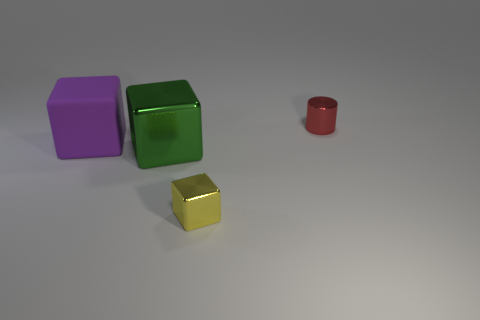What material is the tiny thing to the left of the tiny thing behind the tiny metallic object to the left of the small cylinder made of?
Give a very brief answer. Metal. What shape is the object that is right of the yellow shiny object?
Provide a succinct answer. Cylinder. What is the size of the yellow thing that is the same material as the tiny red thing?
Provide a short and direct response. Small. What number of big green things are the same shape as the large purple matte object?
Give a very brief answer. 1. How many tiny cylinders are behind the large purple cube that is behind the metal cube left of the small yellow block?
Give a very brief answer. 1. What number of things are behind the large shiny object and left of the small block?
Your answer should be very brief. 1. Is there any other thing that is the same material as the red cylinder?
Give a very brief answer. Yes. Is the material of the red object the same as the purple cube?
Make the answer very short. No. What is the shape of the object that is right of the tiny shiny object left of the small red metal object behind the green shiny cube?
Offer a terse response. Cylinder. Are there fewer small yellow shiny objects that are on the left side of the tiny yellow metallic cube than red things that are behind the cylinder?
Make the answer very short. No. 